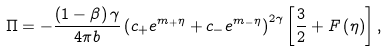<formula> <loc_0><loc_0><loc_500><loc_500>\Pi = - \frac { \left ( 1 - \beta \right ) \gamma } { 4 \pi b } \left ( c _ { + } e ^ { m _ { + } \eta } + c _ { - } e ^ { m _ { - } \eta } \right ) ^ { 2 \gamma } \left [ \frac { 3 } { 2 } + F \left ( \eta \right ) \right ] ,</formula> 